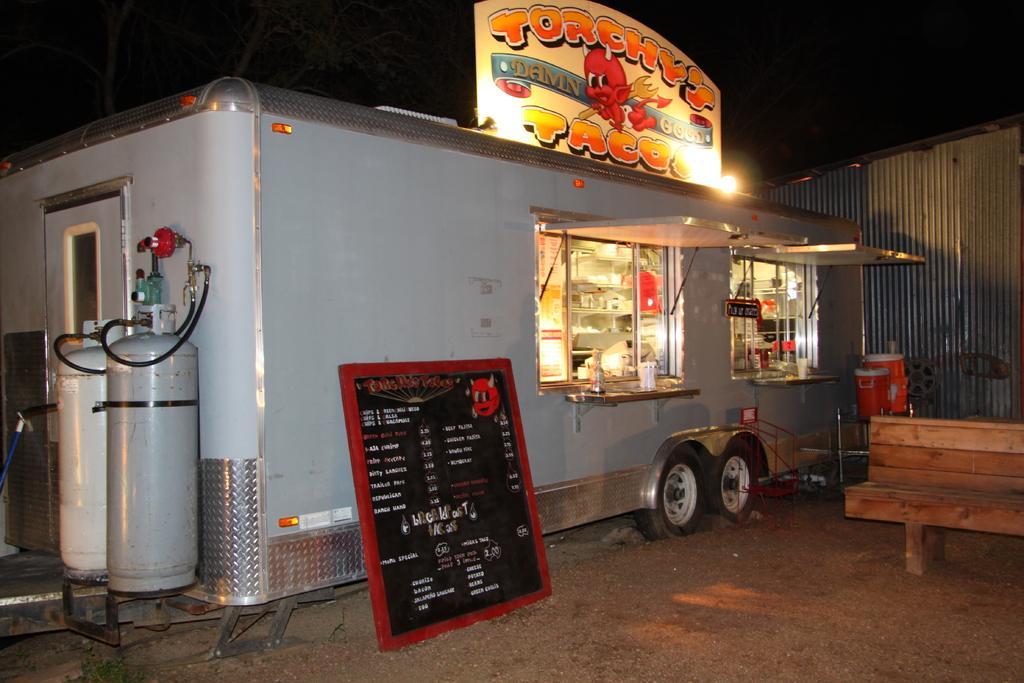How would you summarize this image in a sentence or two? This picture shows a food truck and we see a menu board and a bench 